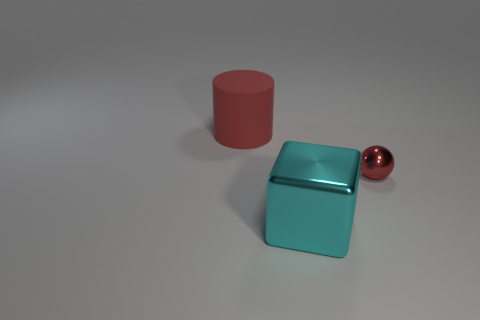Is there anything else that has the same size as the cyan object?
Your answer should be compact. Yes. Is the large object on the left side of the large cyan metal object made of the same material as the tiny red sphere?
Provide a succinct answer. No. What number of other things are there of the same color as the large cylinder?
Your response must be concise. 1. There is a big object that is in front of the tiny metal ball; is it the same shape as the red object on the right side of the red matte thing?
Offer a terse response. No. How many cubes are either small metal things or large things?
Your response must be concise. 1. Are there fewer cyan cubes that are to the left of the cyan thing than large shiny things?
Make the answer very short. Yes. How many other things are there of the same material as the small red ball?
Ensure brevity in your answer.  1. Is the matte thing the same size as the red ball?
Ensure brevity in your answer.  No. What number of things are things in front of the big red cylinder or metal spheres?
Offer a very short reply. 2. There is a red thing that is on the left side of the red thing that is right of the large red cylinder; what is its material?
Offer a very short reply. Rubber. 